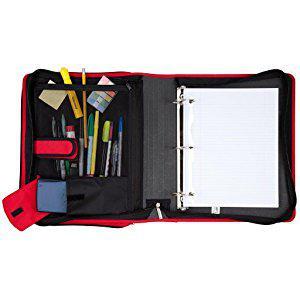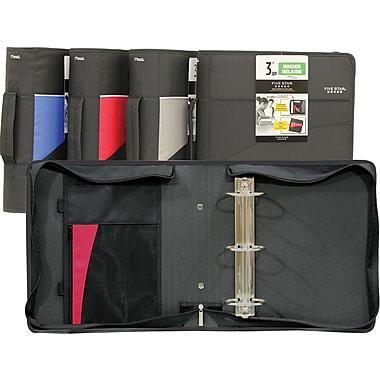The first image is the image on the left, the second image is the image on the right. Given the left and right images, does the statement "Four versions of a binder are standing in a row and overlapping each other." hold true? Answer yes or no. Yes. The first image is the image on the left, the second image is the image on the right. Assess this claim about the two images: "The right image contains at least one open binder and one closed binder.". Correct or not? Answer yes or no. Yes. 